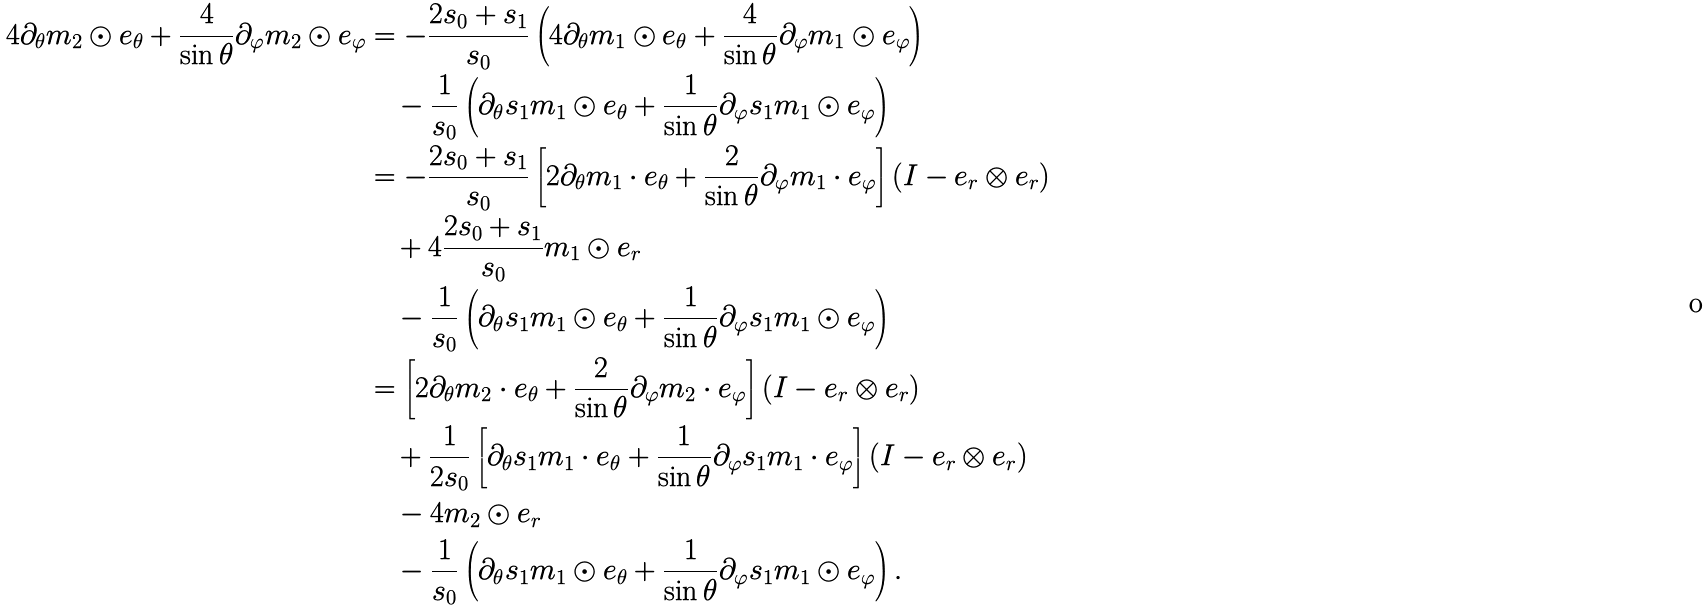Convert formula to latex. <formula><loc_0><loc_0><loc_500><loc_500>4 \partial _ { \theta } m _ { 2 } \odot e _ { \theta } + \frac { 4 } { \sin \theta } \partial _ { \varphi } m _ { 2 } \odot e _ { \varphi } & = - \frac { 2 s _ { 0 } + s _ { 1 } } { s _ { 0 } } \left ( 4 \partial _ { \theta } m _ { 1 } \odot e _ { \theta } + \frac { 4 } { \sin \theta } \partial _ { \varphi } m _ { 1 } \odot e _ { \varphi } \right ) \\ & \quad - \frac { 1 } { s _ { 0 } } \left ( \partial _ { \theta } s _ { 1 } m _ { 1 } \odot e _ { \theta } + \frac { 1 } { \sin \theta } \partial _ { \varphi } s _ { 1 } m _ { 1 } \odot e _ { \varphi } \right ) \\ & = - \frac { 2 s _ { 0 } + s _ { 1 } } { s _ { 0 } } \left [ 2 \partial _ { \theta } m _ { 1 } \cdot e _ { \theta } + \frac { 2 } { \sin \theta } \partial _ { \varphi } m _ { 1 } \cdot e _ { \varphi } \right ] ( I - e _ { r } \otimes e _ { r } ) \\ & \quad + 4 \frac { 2 s _ { 0 } + s _ { 1 } } { s _ { 0 } } m _ { 1 } \odot e _ { r } \\ & \quad - \frac { 1 } { s _ { 0 } } \left ( \partial _ { \theta } s _ { 1 } m _ { 1 } \odot e _ { \theta } + \frac { 1 } { \sin \theta } \partial _ { \varphi } s _ { 1 } m _ { 1 } \odot e _ { \varphi } \right ) \\ & = \left [ 2 \partial _ { \theta } m _ { 2 } \cdot e _ { \theta } + \frac { 2 } { \sin \theta } \partial _ { \varphi } m _ { 2 } \cdot e _ { \varphi } \right ] ( I - e _ { r } \otimes e _ { r } ) \\ & \quad + \frac { 1 } { 2 s _ { 0 } } \left [ \partial _ { \theta } s _ { 1 } m _ { 1 } \cdot e _ { \theta } + \frac { 1 } { \sin \theta } \partial _ { \varphi } s _ { 1 } m _ { 1 } \cdot e _ { \varphi } \right ] ( I - e _ { r } \otimes e _ { r } ) \\ & \quad - 4 m _ { 2 } \odot e _ { r } \\ & \quad - \frac { 1 } { s _ { 0 } } \left ( \partial _ { \theta } s _ { 1 } m _ { 1 } \odot e _ { \theta } + \frac { 1 } { \sin \theta } \partial _ { \varphi } s _ { 1 } m _ { 1 } \odot e _ { \varphi } \right ) .</formula> 